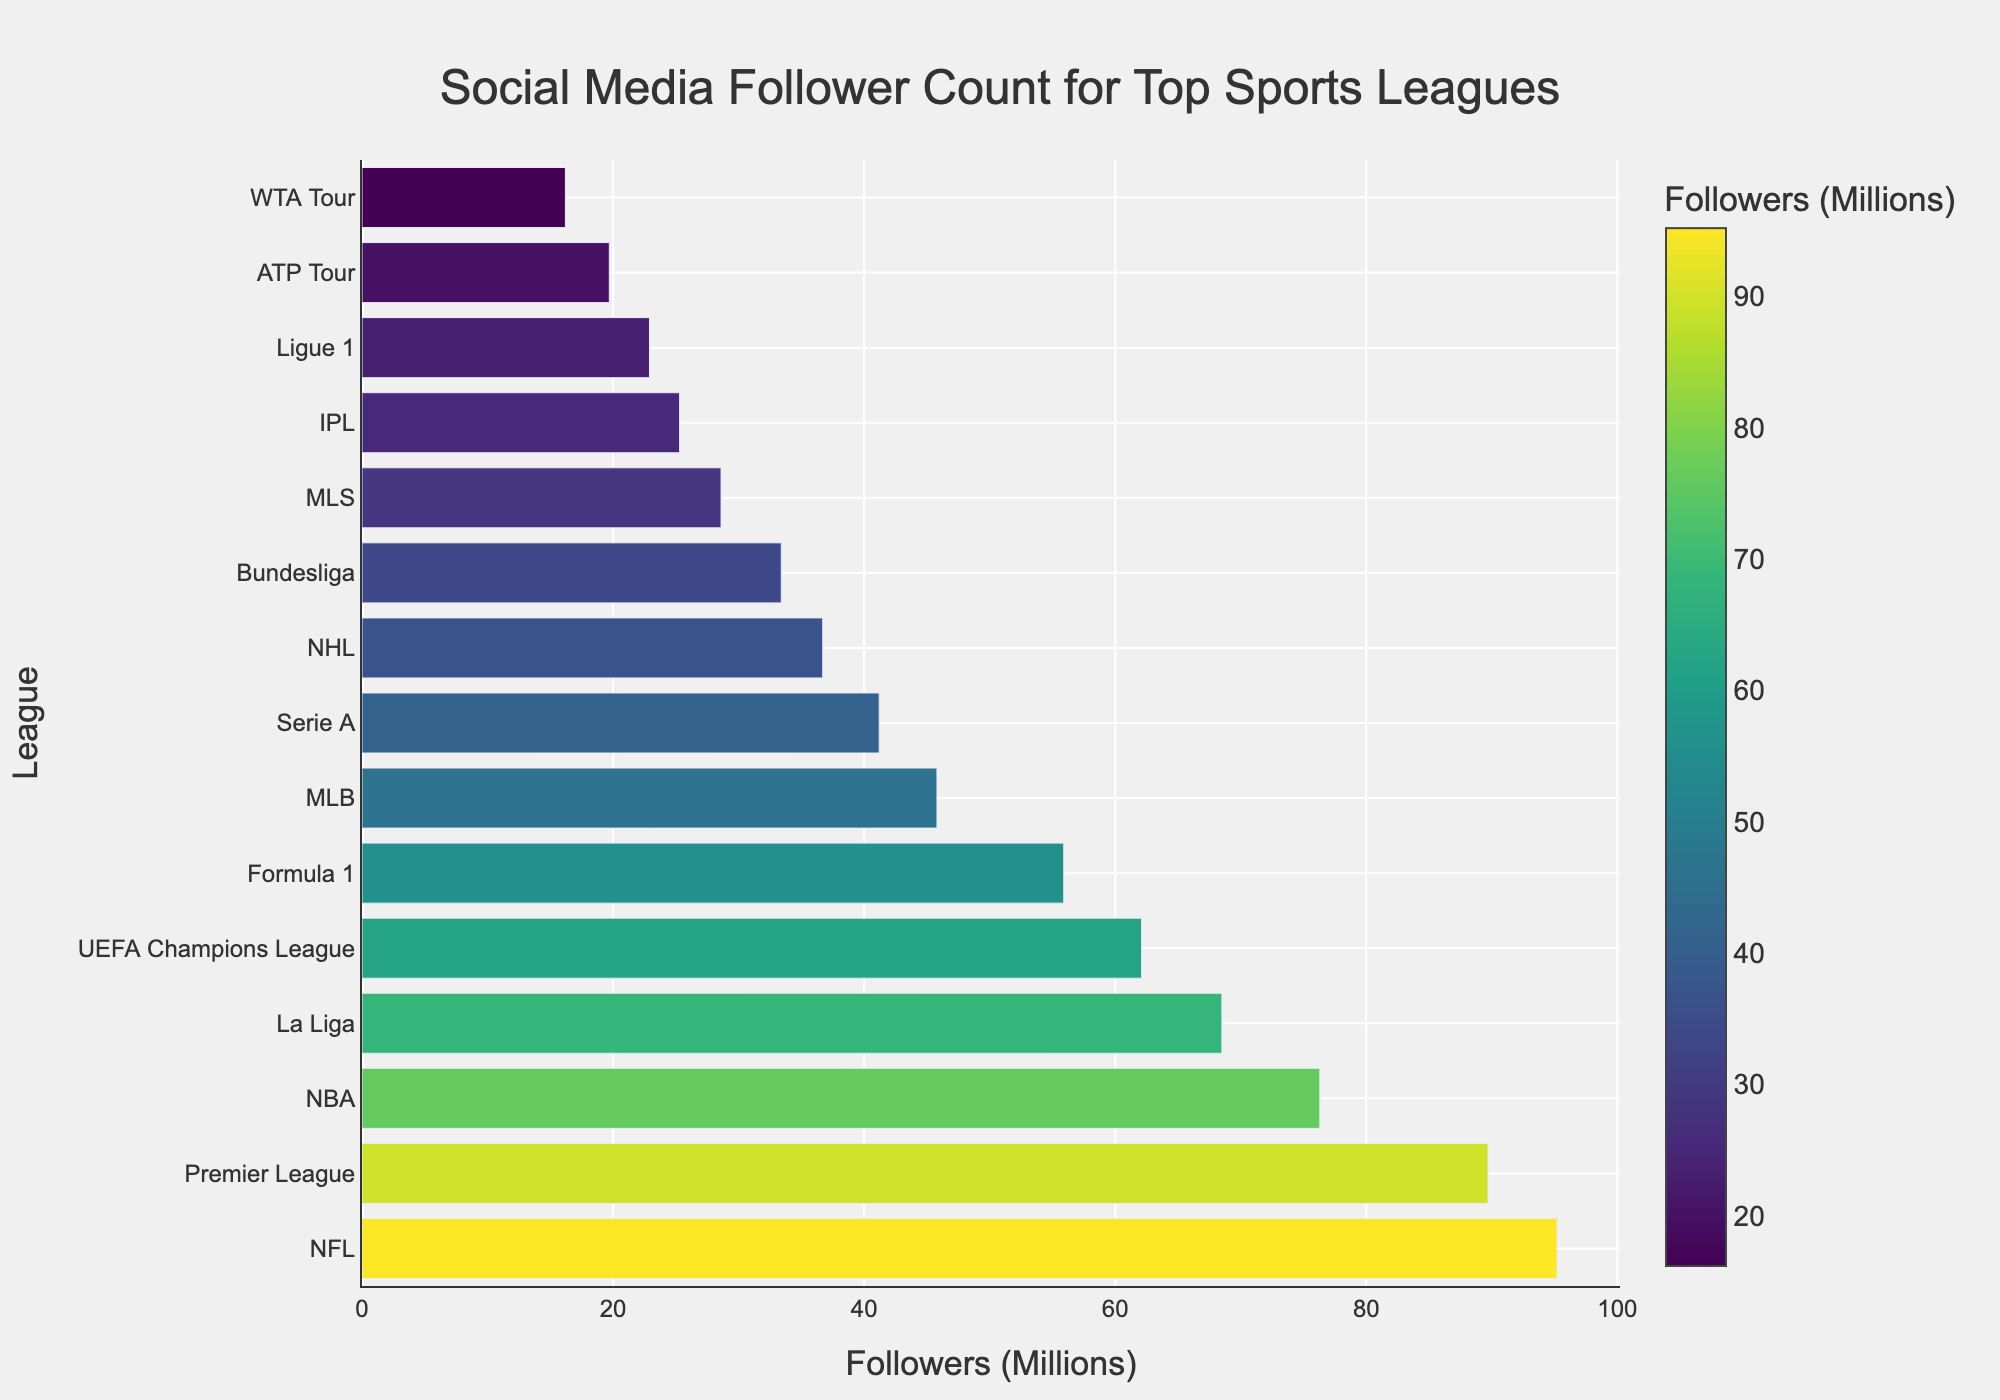What's the league with the highest follower count? Locate the bar with the maximum length, which represents the league with the highest follower count. In this case, it's the first bar, representing the NFL.
Answer: NFL Which league has the smallest follower count? Find the shortest bar in the chart, which represents the league with the fewest followers. The shortest bar is for the WTA Tour.
Answer: WTA Tour What is the difference in followers between the NFL and the Premier League? Check the follower counts for the NFL (95.2 million) and the Premier League (89.7 million), then subtract the latter from the former: 95.2 - 89.7 = 5.5 million.
Answer: 5.5 million Which league has more followers, La Liga or Formula 1? Compare the lengths of the bars representing La Liga (68.5 million) and Formula 1 (55.9 million). La Liga has more followers.
Answer: La Liga What is the total follower count for leagues with over 70 million followers? Identify the leagues with followers more than 70 million: NFL (95.2), Premier League (89.7), and NBA (76.3). Sum these values: 95.2 + 89.7 + 76.3 = 261.2 million.
Answer: 261.2 million How many leagues have more than 50 million followers? Count the number of bars that represent leagues with follower counts exceeding 50 million. These leagues are NFL, Premier League, NBA, La Liga, and UEFA Champions League.
Answer: 5 What is the median follower count of all leagues? List the follower counts in ascending order and find the middle value. Sorted list: 16.2, 19.7, 22.9, 25.3, 28.6, 33.4, 36.7, 41.2, 45.8, 55.9, 62.1, 68.5, 76.3, 89.7, 95.2. The middle value (8th value) is 41.2 million.
Answer: 41.2 million Which league's bar color is the lightest in the chart? Identify the lightest-colored bar, typically associated with the highest value in a Viridis color scale. The lightest bar represents the NFL.
Answer: NFL Comparing the ATP Tour and NHL, which league has fewer followers and by how much? Look at the follower counts: ATP Tour (19.7 million) and NHL (36.7 million). Subtract the smaller count from the larger: 36.7 - 19.7 = 17 million.
Answer: ATP Tour, 17 million How many leagues have a follower count between 40 million and 60 million? Identify bars with follower counts in the range 40 to 60 million. These leagues are Formula 1, MLB, and Serie A.
Answer: 3 